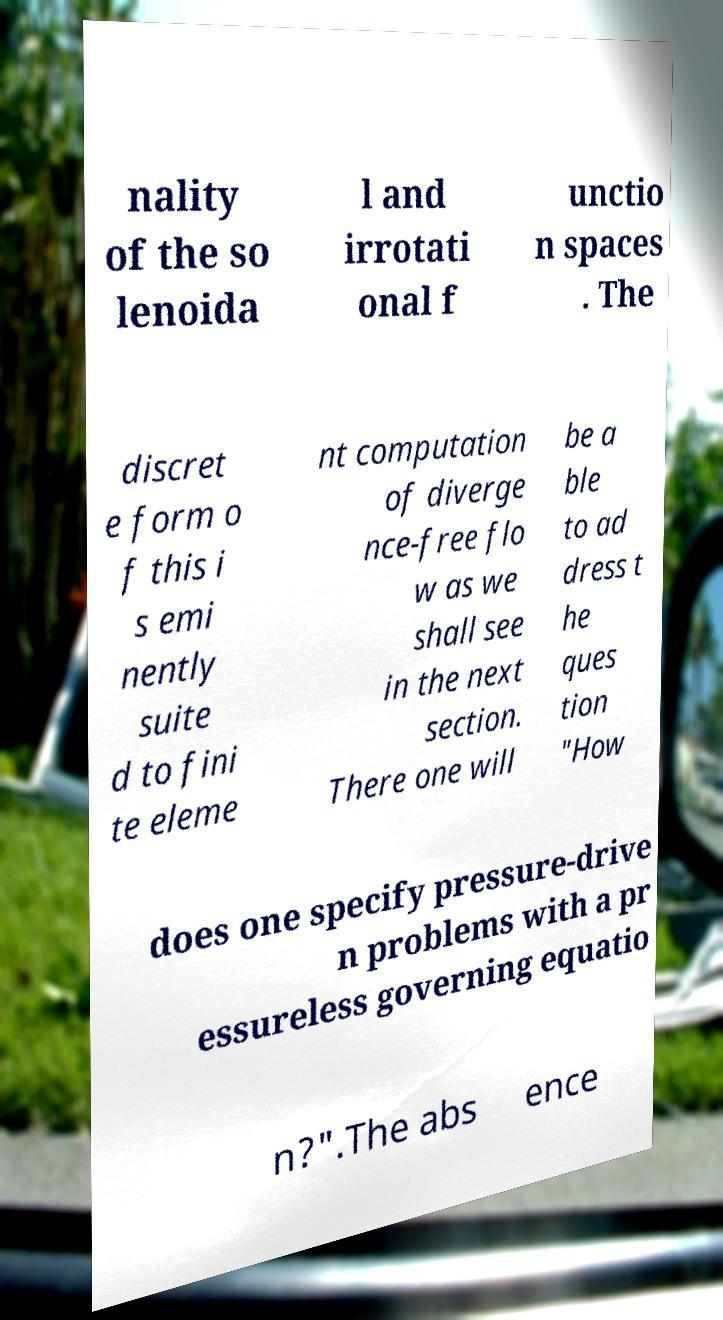Can you read and provide the text displayed in the image?This photo seems to have some interesting text. Can you extract and type it out for me? nality of the so lenoida l and irrotati onal f unctio n spaces . The discret e form o f this i s emi nently suite d to fini te eleme nt computation of diverge nce-free flo w as we shall see in the next section. There one will be a ble to ad dress t he ques tion "How does one specify pressure-drive n problems with a pr essureless governing equatio n?".The abs ence 